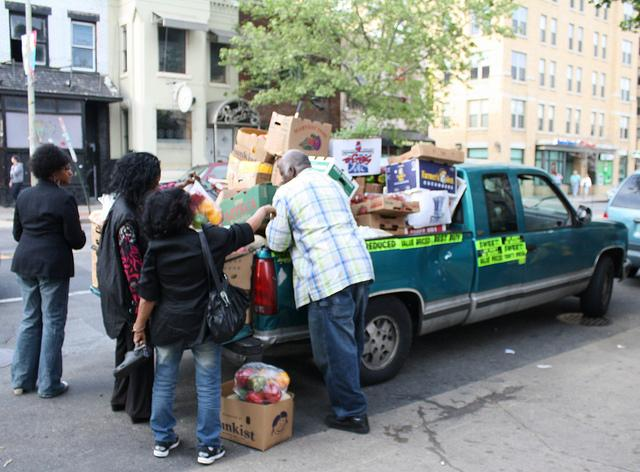Why is there green tape on the pickup? Please explain your reasoning. advertising. The tape is for advertising. 